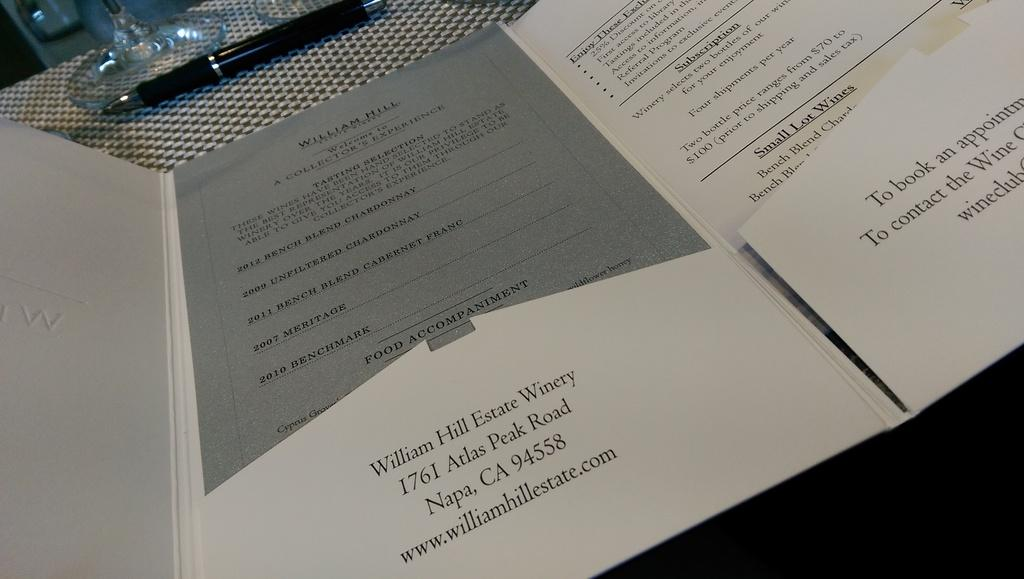What type of document is visible in the image? There is a file with text in the image. What writing instrument is present in the image? There is a pen in the image. What beverage container is in the image? There is a glass in the image. Where are all the objects located in the image? All objects are on a table. What type of steel is used to make the cattle in the image? There is no steel or cattle present in the image. How does the harmony between the objects in the image contribute to the overall aesthetic? The image does not depict any objects interacting in a way that would suggest harmony. 